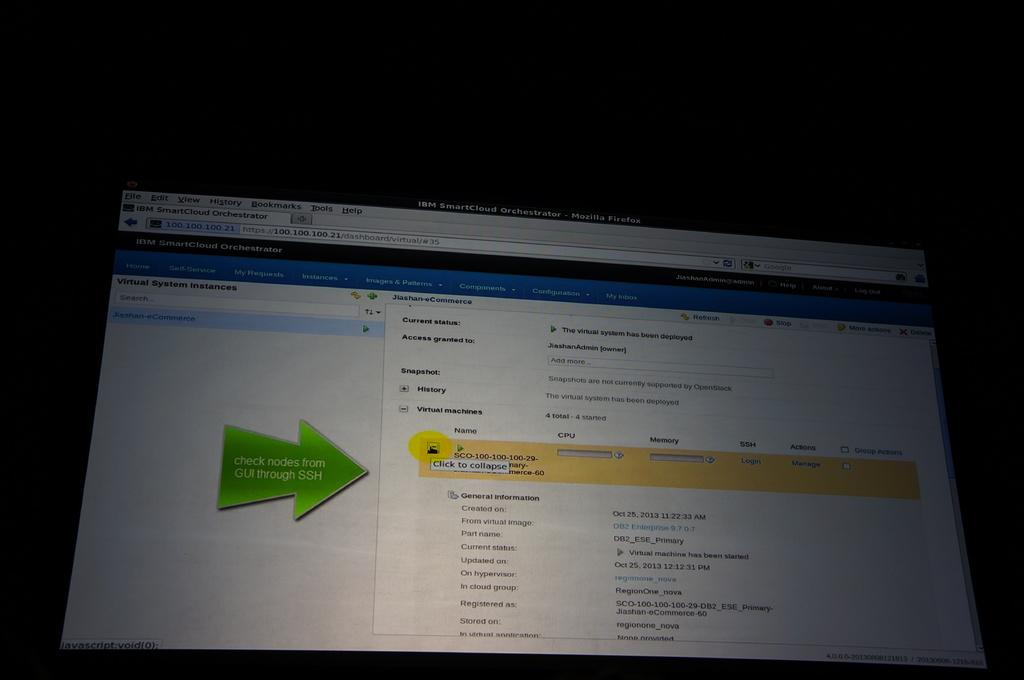<image>
Render a clear and concise summary of the photo. A screen with text on it and a green arrow that says "Check nodes from GUI through SSH" on it. 